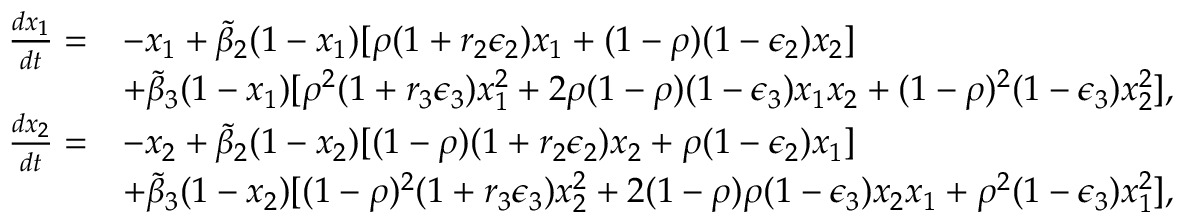Convert formula to latex. <formula><loc_0><loc_0><loc_500><loc_500>\begin{array} { r l } { \frac { d x _ { 1 } } { d t } = } & { - x _ { 1 } + \widetilde { \beta } _ { 2 } ( 1 - x _ { 1 } ) [ \rho ( 1 + r _ { 2 } \epsilon _ { 2 } ) x _ { 1 } + ( 1 - \rho ) ( 1 - \epsilon _ { 2 } ) x _ { 2 } ] } \\ & { + \widetilde { \beta } _ { 3 } ( 1 - x _ { 1 } ) [ \rho ^ { 2 } ( 1 + r _ { 3 } \epsilon _ { 3 } ) x _ { 1 } ^ { 2 } + 2 \rho ( 1 - \rho ) ( 1 - \epsilon _ { 3 } ) x _ { 1 } x _ { 2 } + ( 1 - \rho ) ^ { 2 } ( 1 - \epsilon _ { 3 } ) x _ { 2 } ^ { 2 } ] , } \\ { \frac { d x _ { 2 } } { d t } = } & { - x _ { 2 } + \widetilde { \beta } _ { 2 } ( 1 - x _ { 2 } ) [ ( 1 - \rho ) ( 1 + r _ { 2 } \epsilon _ { 2 } ) x _ { 2 } + \rho ( 1 - \epsilon _ { 2 } ) x _ { 1 } ] } \\ & { + \widetilde { \beta } _ { 3 } ( 1 - x _ { 2 } ) [ ( 1 - \rho ) ^ { 2 } ( 1 + r _ { 3 } \epsilon _ { 3 } ) x _ { 2 } ^ { 2 } + 2 ( 1 - \rho ) \rho ( 1 - \epsilon _ { 3 } ) x _ { 2 } x _ { 1 } + \rho ^ { 2 } ( 1 - \epsilon _ { 3 } ) x _ { 1 } ^ { 2 } ] , } \end{array}</formula> 